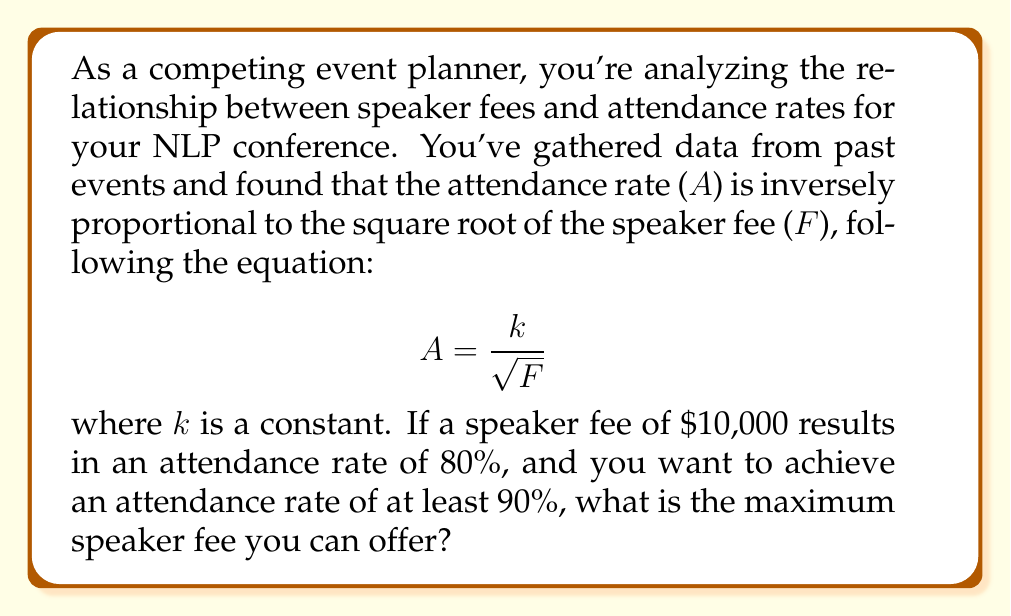Show me your answer to this math problem. Let's approach this step-by-step:

1) First, we need to find the value of $k$ using the given information:
   $$ 80 = \frac{k}{\sqrt{10000}} $$

2) Simplify:
   $$ 80 = \frac{k}{100} $$

3) Solve for $k$:
   $$ k = 80 * 100 = 8000 $$

4) Now that we know $k$, we can set up the inequality for the desired attendance rate:
   $$ 90 \leq \frac{8000}{\sqrt{F}} $$

5) Solve for $F$:
   $$ 90\sqrt{F} \leq 8000 $$
   $$ \sqrt{F} \leq \frac{8000}{90} $$
   $$ F \leq (\frac{8000}{90})^2 $$

6) Calculate the result:
   $$ F \leq (\frac{8000}{90})^2 \approx 7901.23 $$

Therefore, the maximum speaker fee you can offer while maintaining an attendance rate of at least 90% is approximately $\$7,901.23$.
Answer: $\$7,901.23 